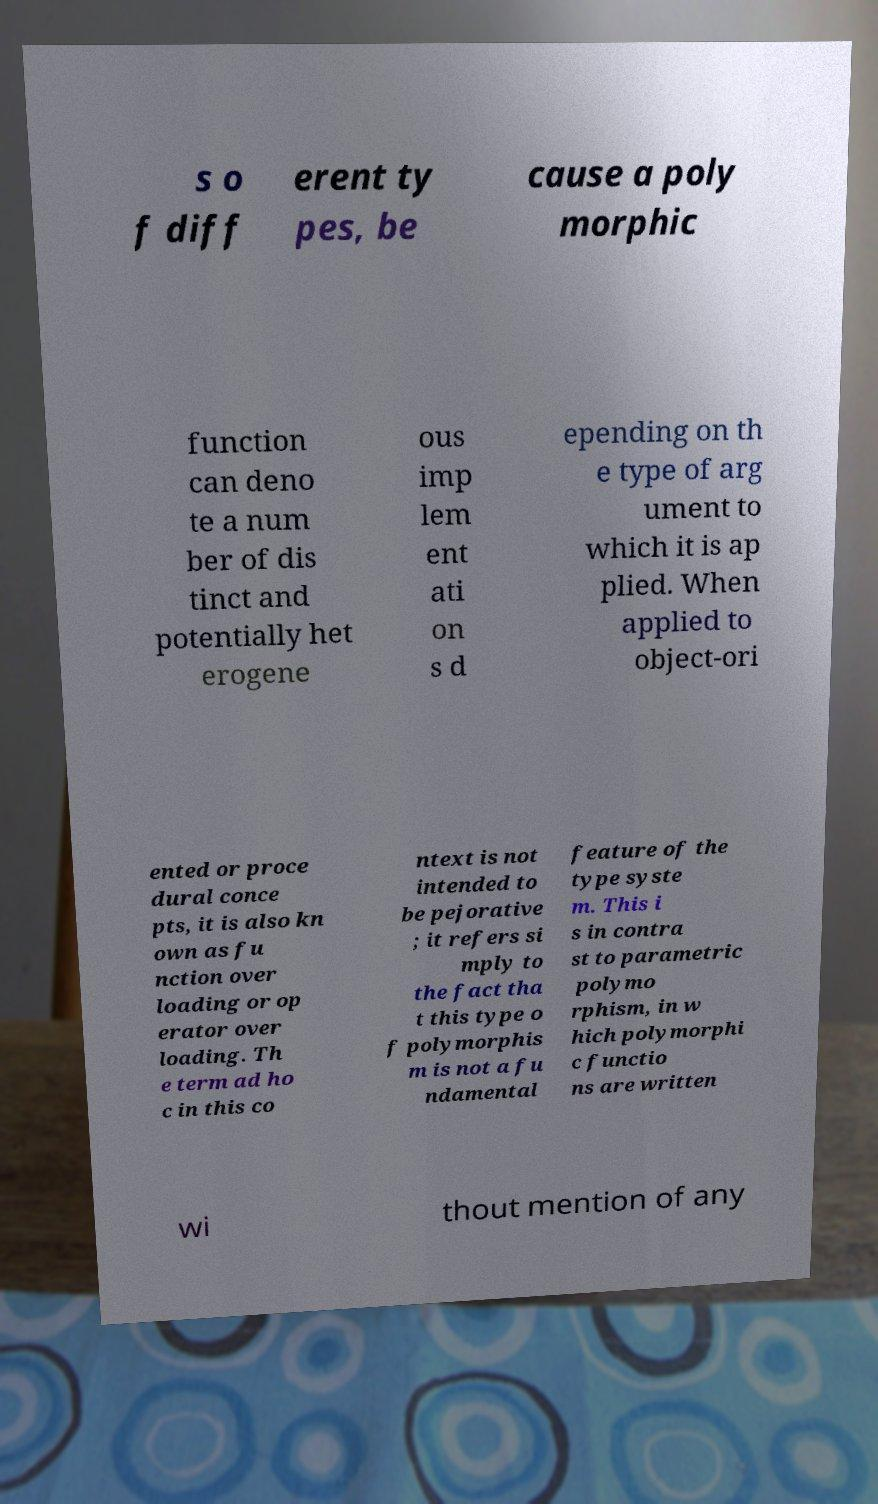I need the written content from this picture converted into text. Can you do that? s o f diff erent ty pes, be cause a poly morphic function can deno te a num ber of dis tinct and potentially het erogene ous imp lem ent ati on s d epending on th e type of arg ument to which it is ap plied. When applied to object-ori ented or proce dural conce pts, it is also kn own as fu nction over loading or op erator over loading. Th e term ad ho c in this co ntext is not intended to be pejorative ; it refers si mply to the fact tha t this type o f polymorphis m is not a fu ndamental feature of the type syste m. This i s in contra st to parametric polymo rphism, in w hich polymorphi c functio ns are written wi thout mention of any 